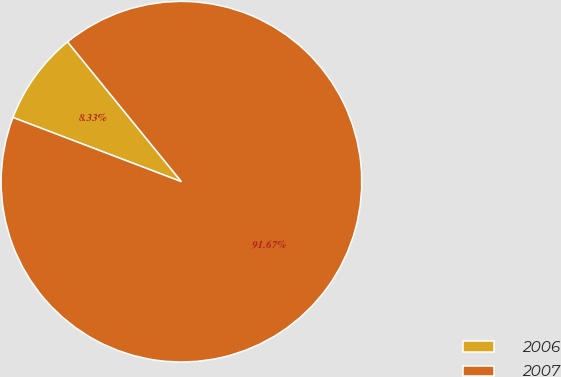Convert chart. <chart><loc_0><loc_0><loc_500><loc_500><pie_chart><fcel>2006<fcel>2007<nl><fcel>8.33%<fcel>91.67%<nl></chart> 